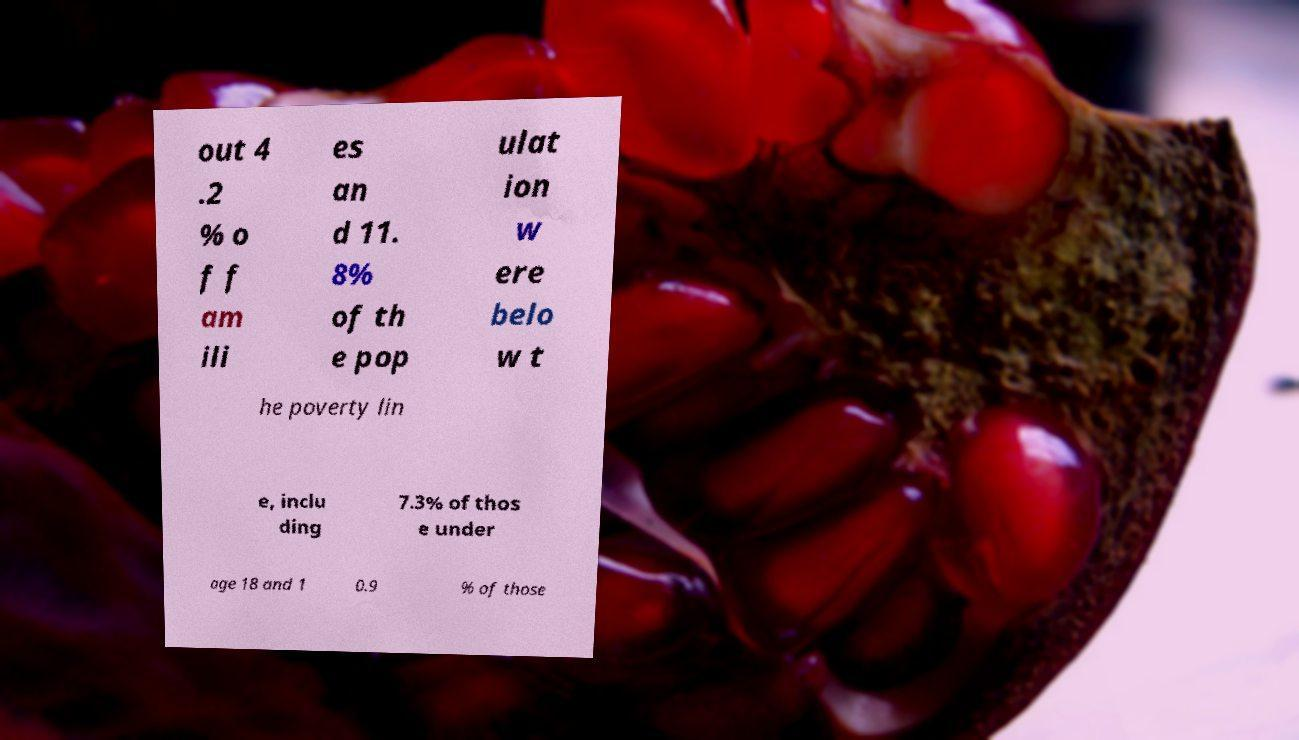I need the written content from this picture converted into text. Can you do that? out 4 .2 % o f f am ili es an d 11. 8% of th e pop ulat ion w ere belo w t he poverty lin e, inclu ding 7.3% of thos e under age 18 and 1 0.9 % of those 